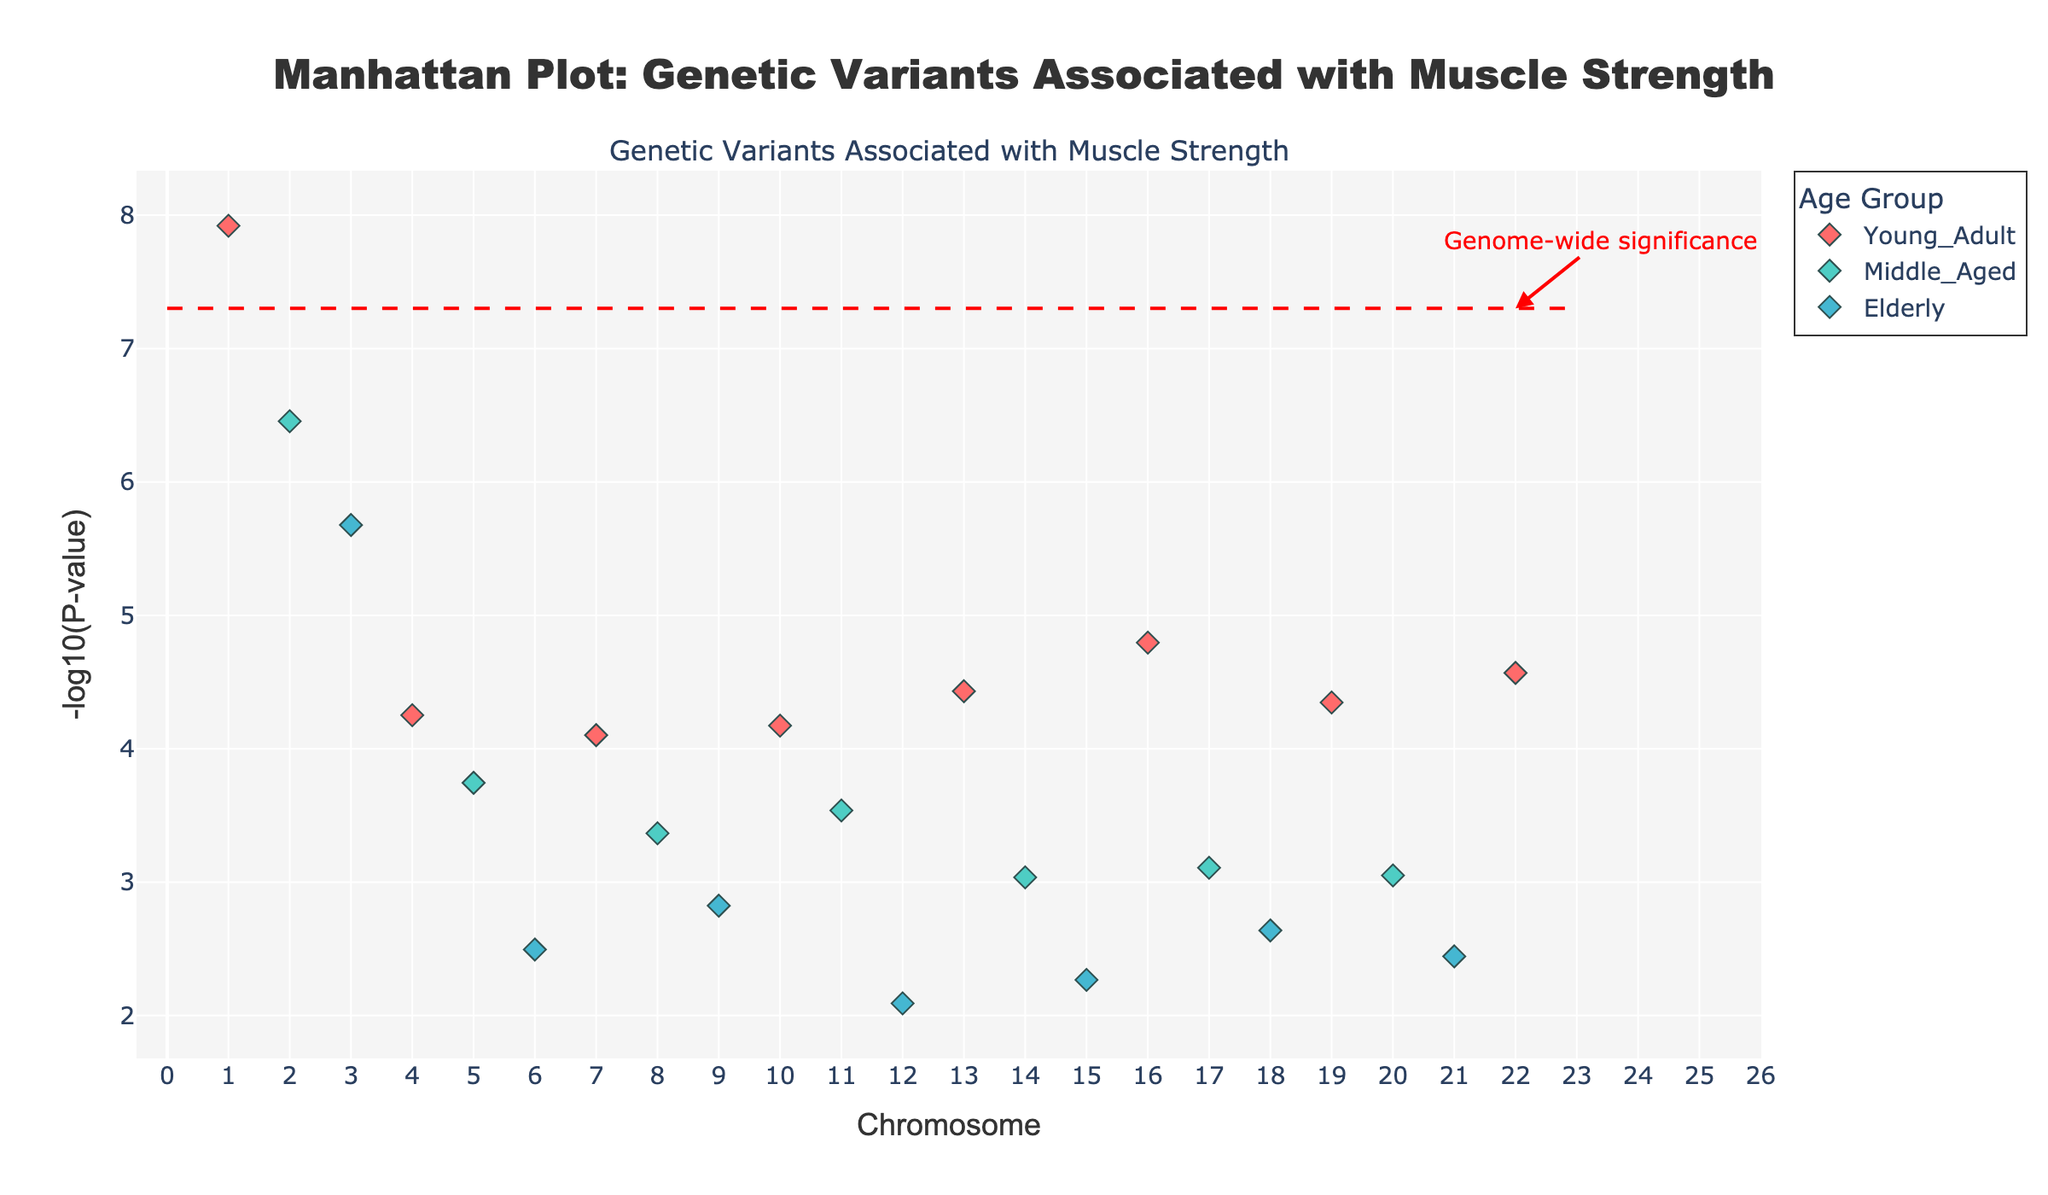How many age groups are represented in the plot? There are different colors representing each age group. By looking at the legend, we can see there are three age groups: Young Adult, Middle Aged, and Elderly.
Answer: 3 What does the horizontal dashed line in the plot represent? The horizontal dashed line is placed at -log10(5e-8), which is annotated as "Genome-wide significance". It represents a threshold below which the genetic variants are considered genome-wide significant.
Answer: Genome-wide significance Which chromosome has the most significant genetic variant associated with muscle strength? By looking at the points that are the highest on the y-axis, we see that chromosome 1 has a point with the highest -log10(p) value.
Answer: Chromosome 1 What is the gene associated with the highest -log10(P-value) in Young Adults? In Young Adults, the highest -log10(P-value) point is on Chromosome 1. The hover text or data would show it is the ACTN3 gene.
Answer: ACTN3 Which gene has the smallest P-value for Middle Aged individuals? For Middle Aged individuals, we need to find the highest point on the y-axis, which is on Chromosome 2, associated with the MSTN gene.
Answer: MSTN Compare the significance levels of the ACTN3 gene in Young Adults and the MSTN gene in Middle Aged individuals. Which one is more significant? The ACTN3 gene in Young Adults (on Chromosome 1) has a higher -log10(P-value) compared to the MSTN gene in Middle Aged individuals (on Chromosome 2). Higher -log10(P-value) indicates a smaller P-value, thus more significant.
Answer: ACTN3 What is the total number of genes plotted in the Manhattan plot? By counting all unique data points on the plot, we can see the number of genes represented. There are 22 unique genes listed in the data.
Answer: 22 Which age group has the most genes passing the genome-wide significance threshold? By looking for the clusters of points above the horizontal dashed line, we see the majority of such genes belong to the Young Adult group, identified through their color in the plot.
Answer: Young Adult What is the range of P-values plotted in this Manhattan plot? To find the range of P-values, we need to look at the maximum and minimum -log10(P-value) on the y-axis. The minimum -log10(P-value) can be seen at the lowest points on the y-axis, which corresponds to P=8.1e-3. The maximum corresponds to the highest points, P=1.2e-8.
Answer: 1.2e-8 to 8.1e-3 